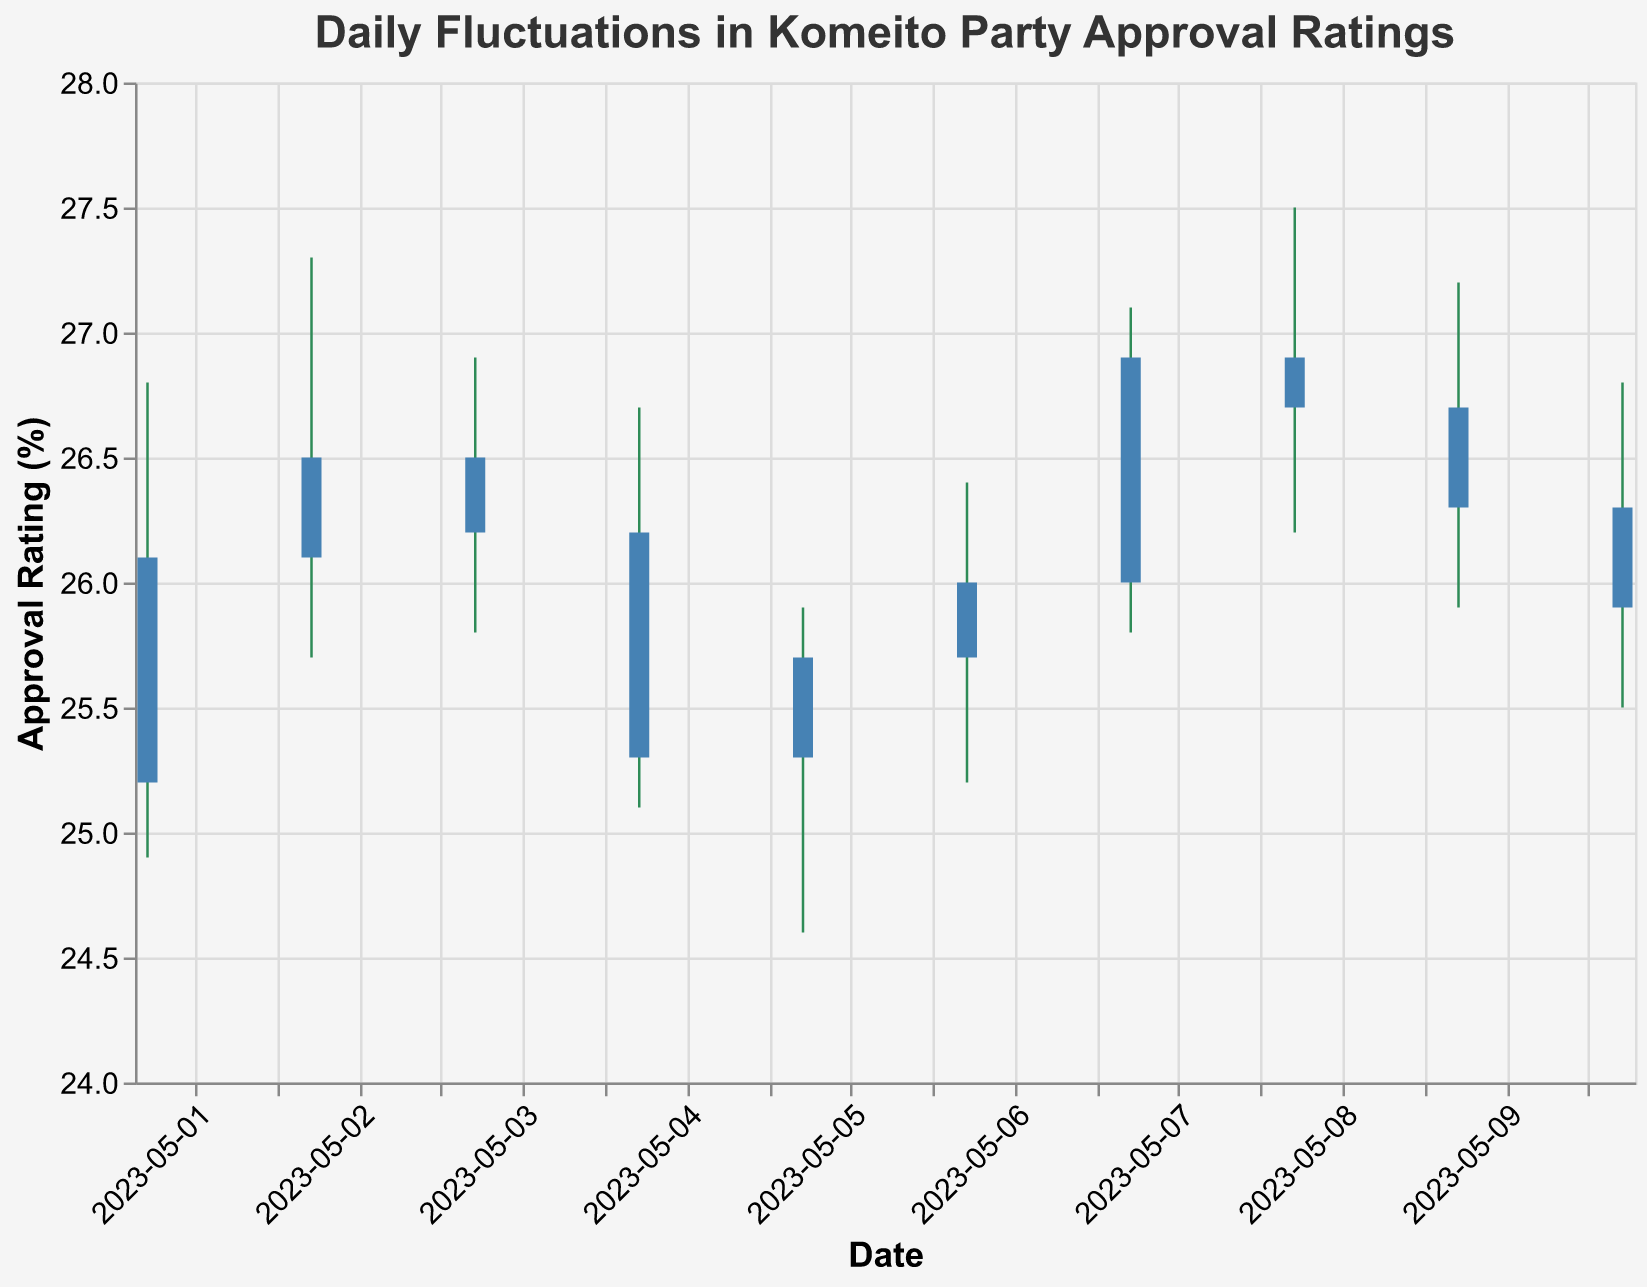What's the title of the chart? The title of the chart is displayed prominently at the top, usually in large font. The title here is "Daily Fluctuations in Komeito Party Approval Ratings".
Answer: Daily Fluctuations in Komeito Party Approval Ratings How many days are represented in the chart? Count the number of data points along the x-axis, with each representing a date. Here, there are 10 data points from May 1 to May 10, 2023.
Answer: 10 On which date did the Komeito party have the highest approval rating? Look at the "High" values for each date to determine the peak approval rating. The highest approval rating of 27.5% occurred on May 8, 2023.
Answer: May 8, 2023 What was the range of the approval rating on May 5, 2023? The range is the difference between the "High" and "Low" values for May 5. The high was 25.9% and the low was 24.6%, resulting in a range of 25.9 - 24.6 = 1.3%.
Answer: 1.3% Which dates saw a decrease in approval rating compared to the previous day? Identify days where the "Close" value is lower than the previous day's "Close". These are May 3 (26.2% to 25.3%), May 10 (26.3% to 25.9%).
Answer: May 3, May 10 What was the average closing approval rating over these dates? Sum all the "Close" values and then divide by the number of data points. (26.1 + 26.5 + 26.2 + 25.3 + 25.7 + 26.0 + 26.9 + 26.7 + 26.3 + 25.9) / 10 = 25.96%.
Answer: 25.96% Which date had the smallest difference between the high and low approval ratings? Calculate the difference between "High" and "Low" for each date and find the minimum. May 6 had the smallest difference: 26.4 - 25.2 = 1.2%.
Answer: May 6, 2023 What was the highest opening approval rating within the given dates? Look at the "Open" values and identify the highest one. The highest opening value is 26.9% on May 8 and May 9.
Answer: 26.9% How did the closing approval rating change from May 1 to May 2? Subtract the closing value of May 1 from the closing value on May 2. It's a change from 26.1% to 26.5%, an increase of 0.4%.
Answer: Increased by 0.4% Between May 4 and May 7, when did the Komeito party's closing rating return to a value close to 26%? Check the "Close" values for May 4, May 5, May 6, and May 7. May 6 has a closing value closest to 26% at 26.0%.
Answer: May 6, 2023 